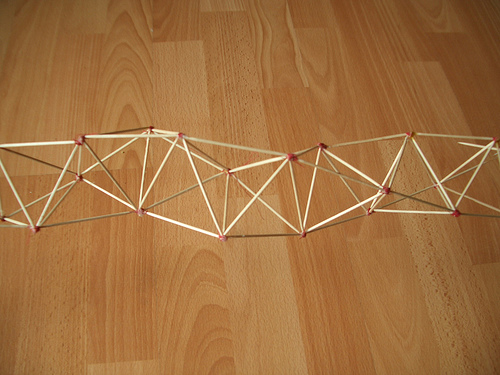<image>
Is the stick on the floor? Yes. Looking at the image, I can see the stick is positioned on top of the floor, with the floor providing support. 